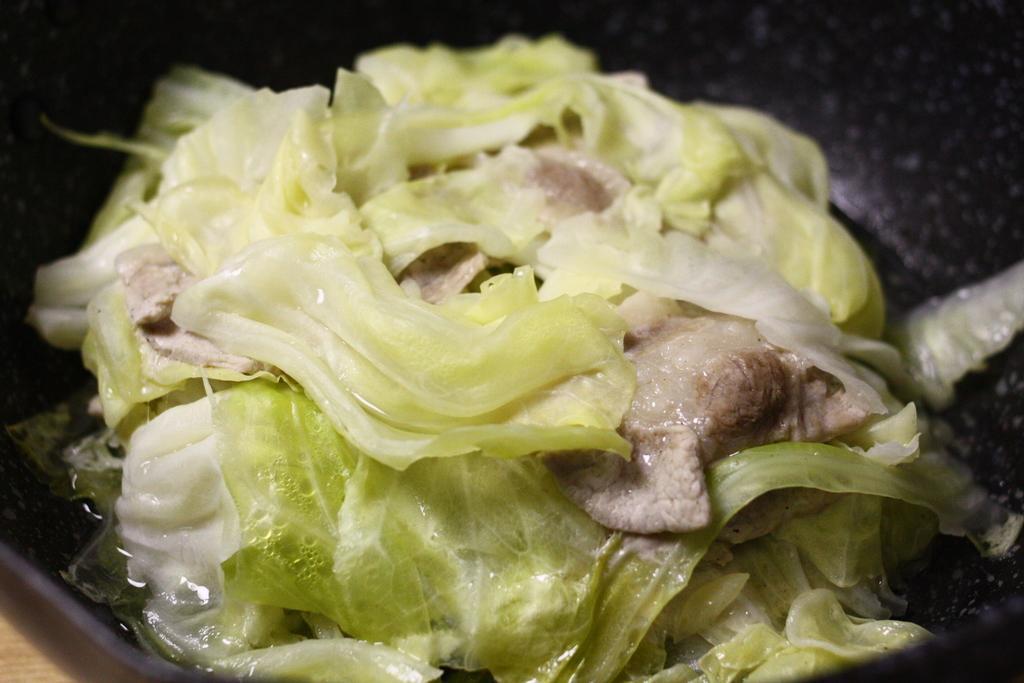Could you give a brief overview of what you see in this image? This image consists of a food which is in the center. 